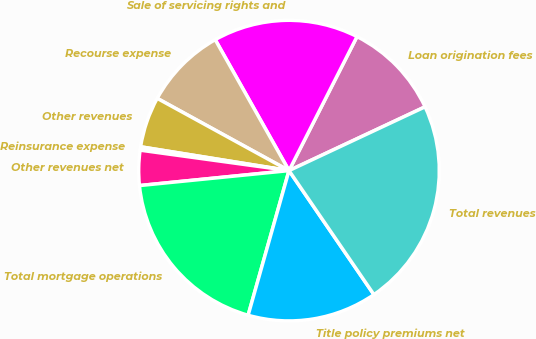Convert chart. <chart><loc_0><loc_0><loc_500><loc_500><pie_chart><fcel>Loan origination fees<fcel>Sale of servicing rights and<fcel>Recourse expense<fcel>Other revenues<fcel>Reinsurance expense<fcel>Other revenues net<fcel>Total mortgage operations<fcel>Title policy premiums net<fcel>Total revenues<nl><fcel>10.55%<fcel>15.64%<fcel>8.85%<fcel>5.45%<fcel>0.36%<fcel>3.76%<fcel>19.03%<fcel>13.94%<fcel>22.42%<nl></chart> 